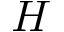Convert formula to latex. <formula><loc_0><loc_0><loc_500><loc_500>H</formula> 